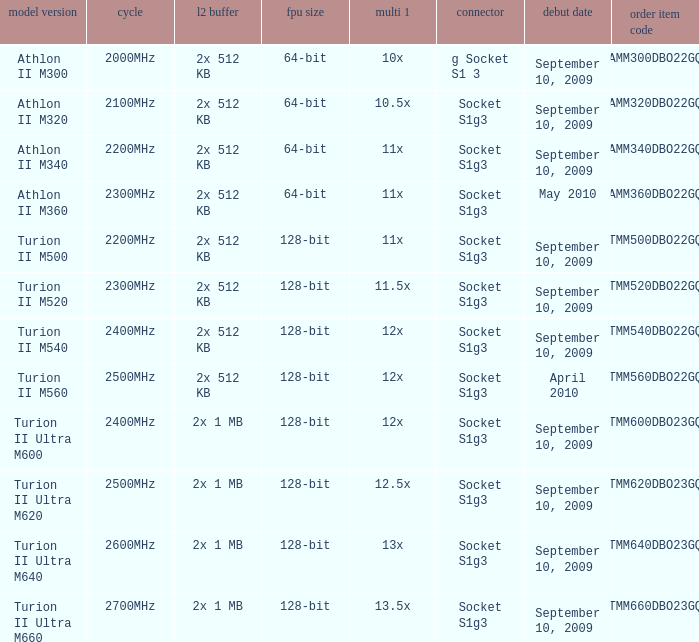What is the release date of the 2x 512 kb L2 cache with a 11x multi 1, and a FPU width of 128-bit? September 10, 2009. 